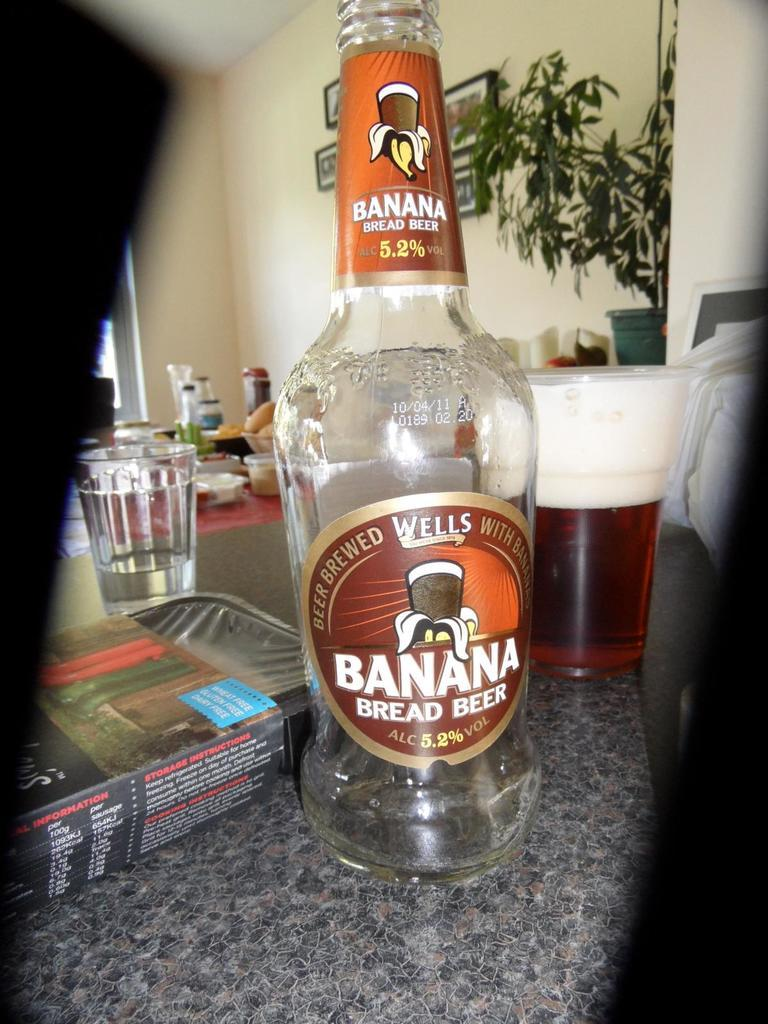<image>
Summarize the visual content of the image. The unusual beer is flavoured with banana bread. 